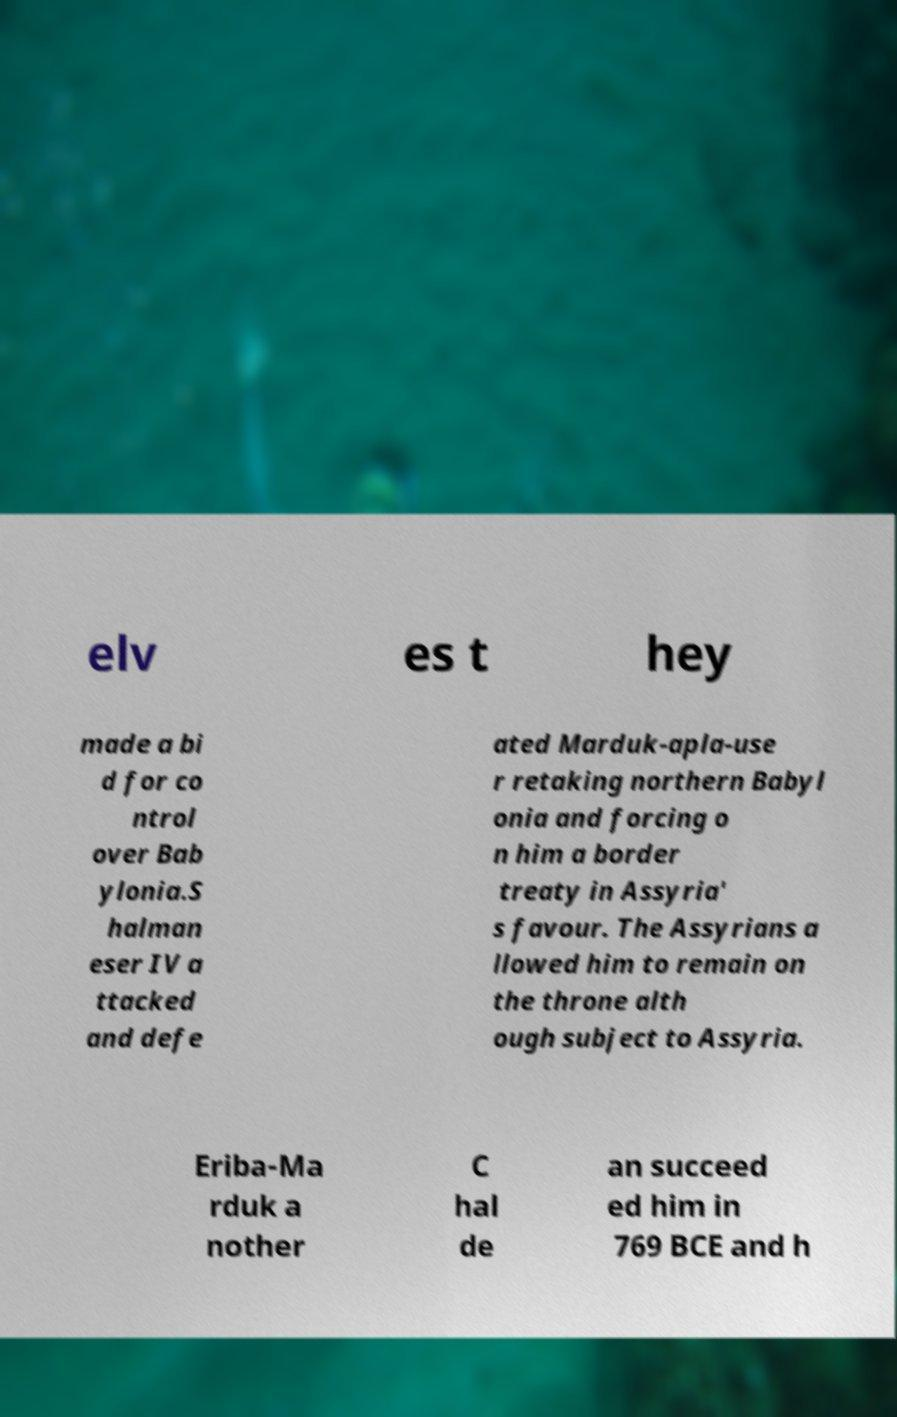There's text embedded in this image that I need extracted. Can you transcribe it verbatim? elv es t hey made a bi d for co ntrol over Bab ylonia.S halman eser IV a ttacked and defe ated Marduk-apla-use r retaking northern Babyl onia and forcing o n him a border treaty in Assyria' s favour. The Assyrians a llowed him to remain on the throne alth ough subject to Assyria. Eriba-Ma rduk a nother C hal de an succeed ed him in 769 BCE and h 